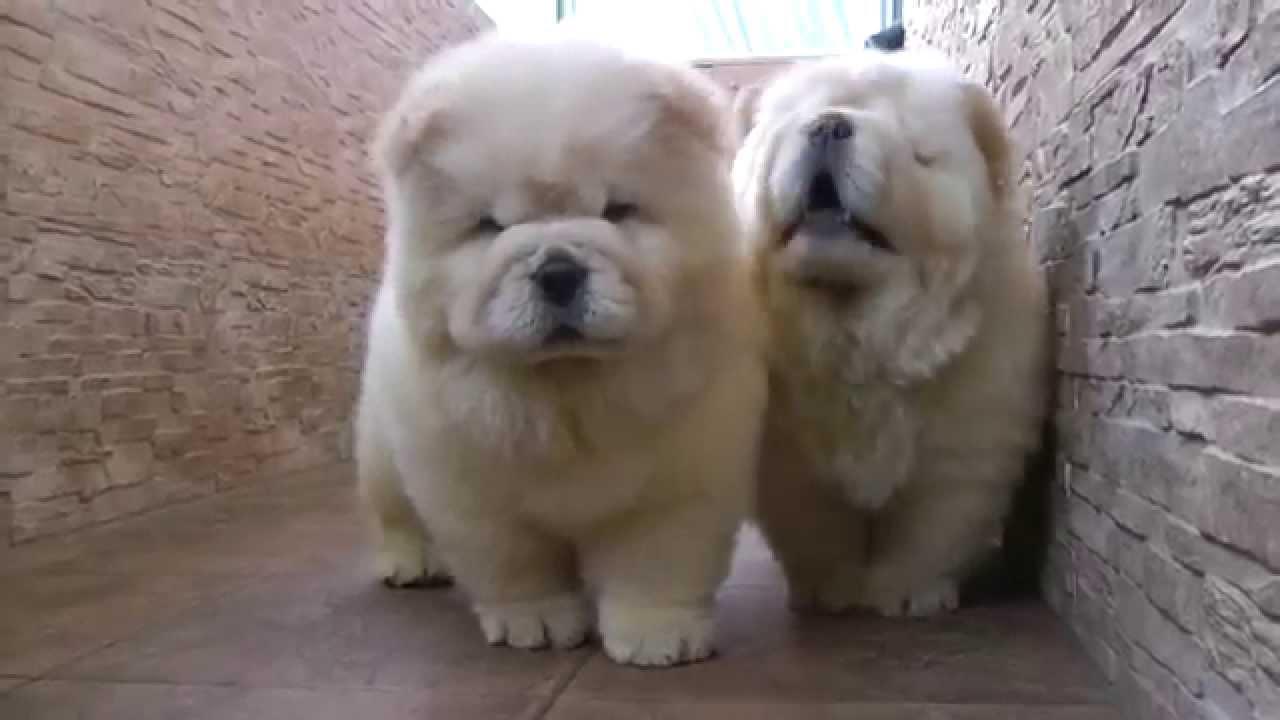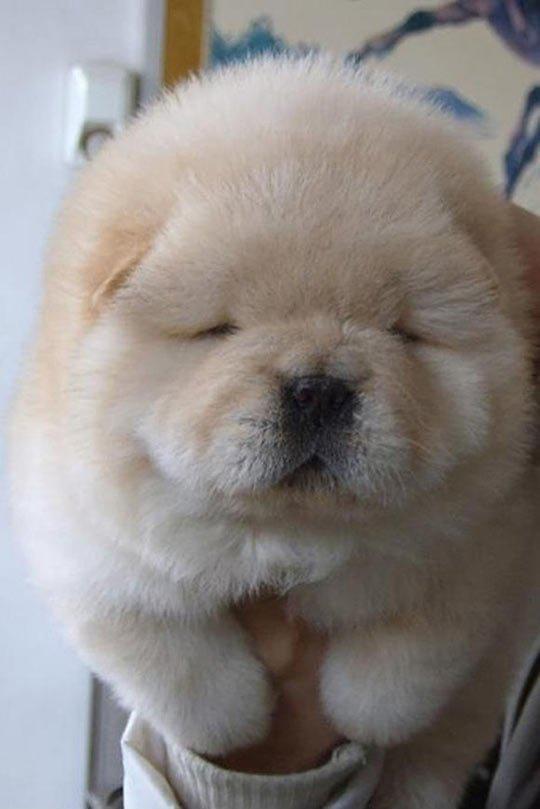The first image is the image on the left, the second image is the image on the right. Assess this claim about the two images: "THere are exactly two dogs in the image on the left.". Correct or not? Answer yes or no. Yes. The first image is the image on the left, the second image is the image on the right. For the images shown, is this caption "An image shows two chow puppies side by side between stone walls." true? Answer yes or no. Yes. 